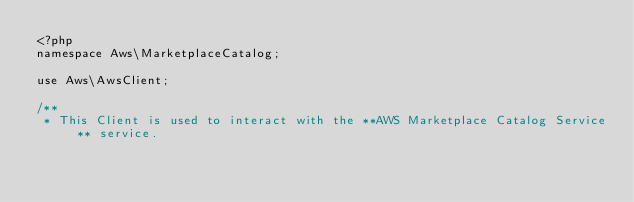Convert code to text. <code><loc_0><loc_0><loc_500><loc_500><_PHP_><?php
namespace Aws\MarketplaceCatalog;

use Aws\AwsClient;

/**
 * This Client is used to interact with the **AWS Marketplace Catalog Service** service.</code> 